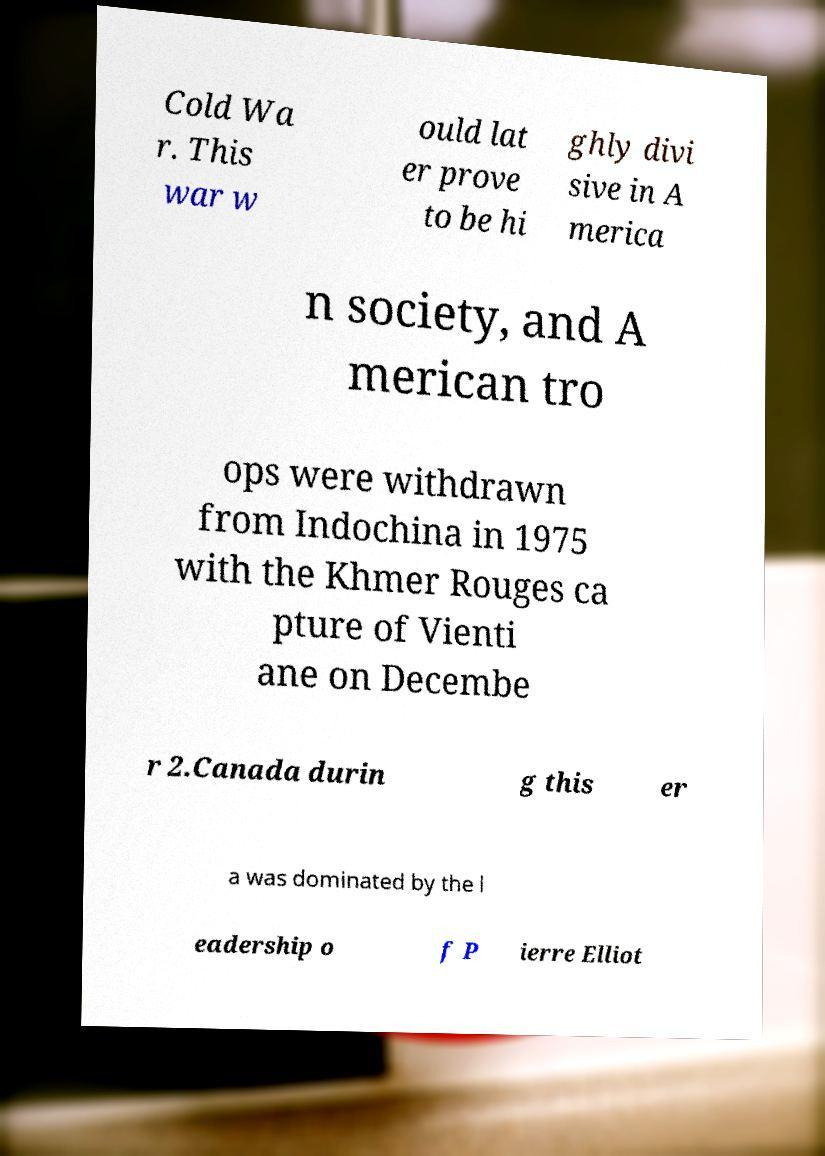Could you assist in decoding the text presented in this image and type it out clearly? Cold Wa r. This war w ould lat er prove to be hi ghly divi sive in A merica n society, and A merican tro ops were withdrawn from Indochina in 1975 with the Khmer Rouges ca pture of Vienti ane on Decembe r 2.Canada durin g this er a was dominated by the l eadership o f P ierre Elliot 